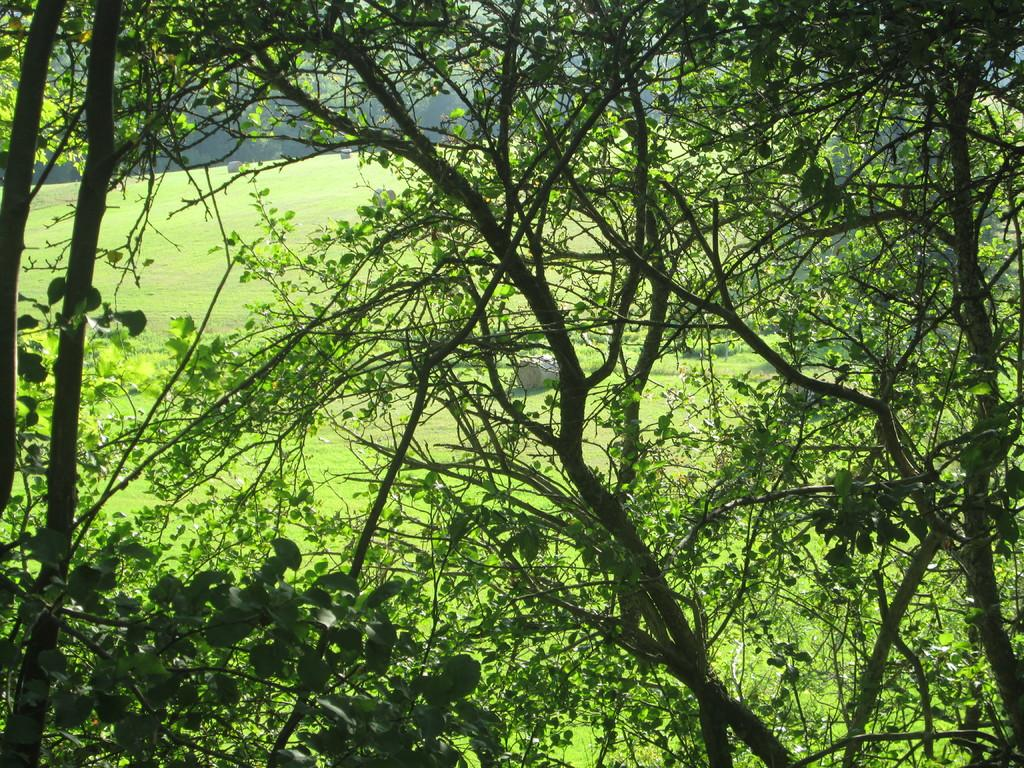What type of vegetation can be seen in the image? There are trees in the image. What can be seen in the background of the image? There is grass visible in the background of the image. How many sisters are sitting on the grass in the image? There are no sisters present in the image; it only features trees and grass. 